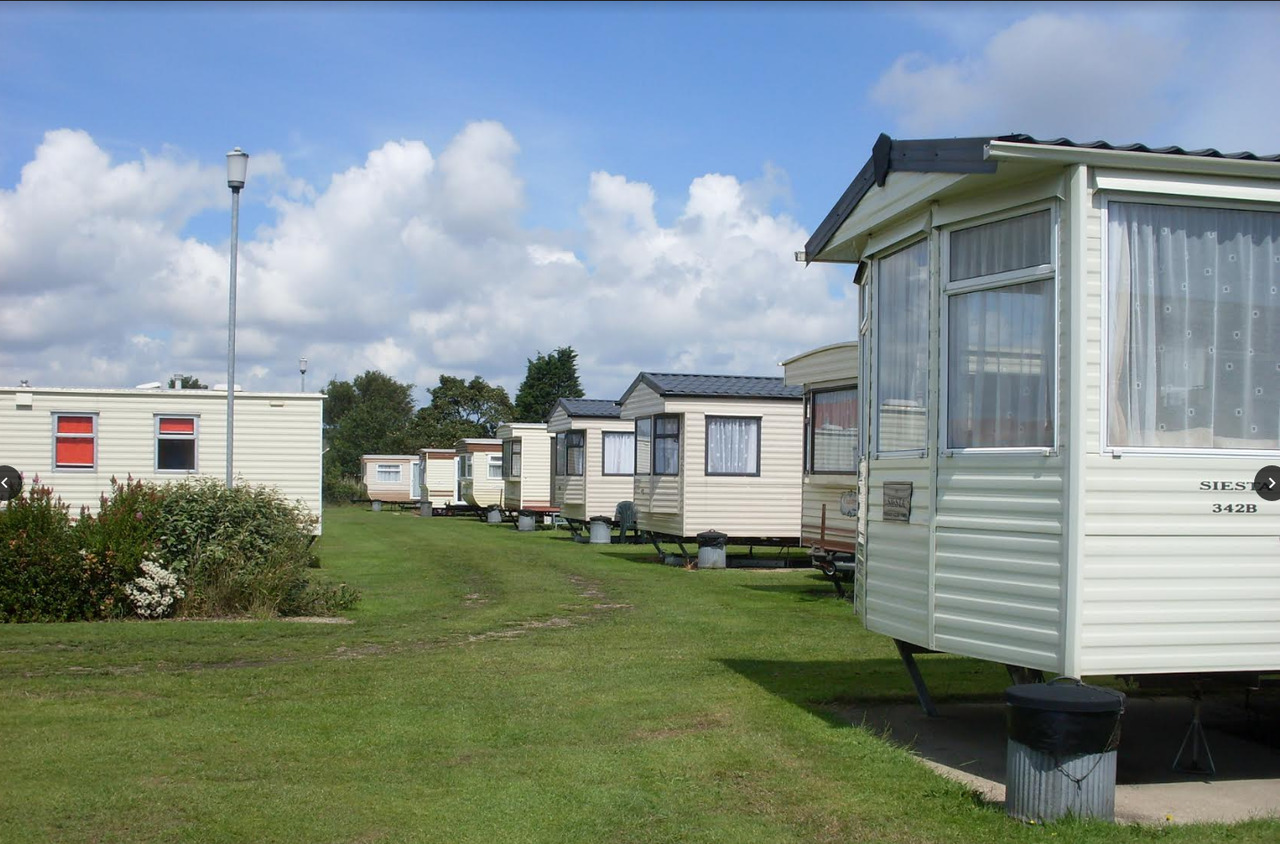What amenities might the residents expect to find within this caravan park? Residents in this caravan park would likely expect amenities such as a central communal area, laundry facilities, a small convenience store, well-maintained restrooms and showers, and perhaps a recreational area with playgrounds or sports facilities. Given the natural surroundings, there might also be picnic areas and walking trails. What could you say about the sense of community in this caravan park? The layout of the caravan park, with caravans arranged in rows and communal grassy areas, suggests a close-knit community. Shared spaces such as central paths and likely communal areas promote interaction among residents, fostering a friendly and sociable environment. Regular foot traffic along shared pathways further indicates that residents frequently encounter one another, enhancing communal bonds. 